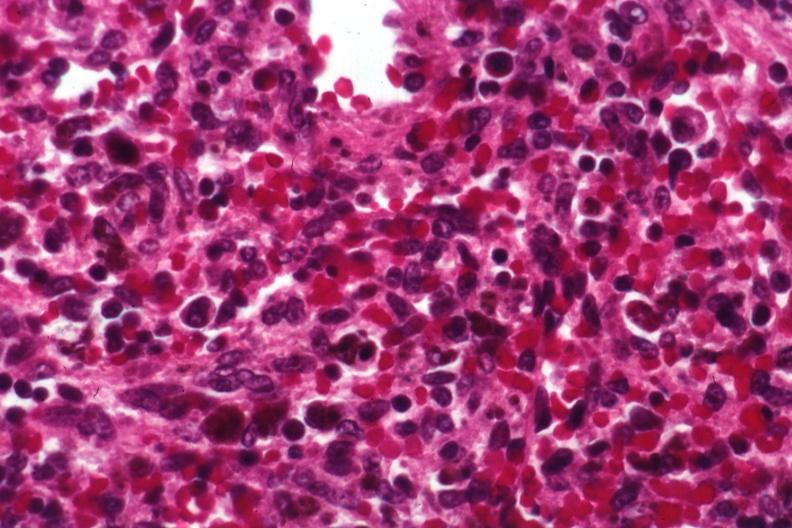what is present?
Answer the question using a single word or phrase. Erythrophagocytosis new born 